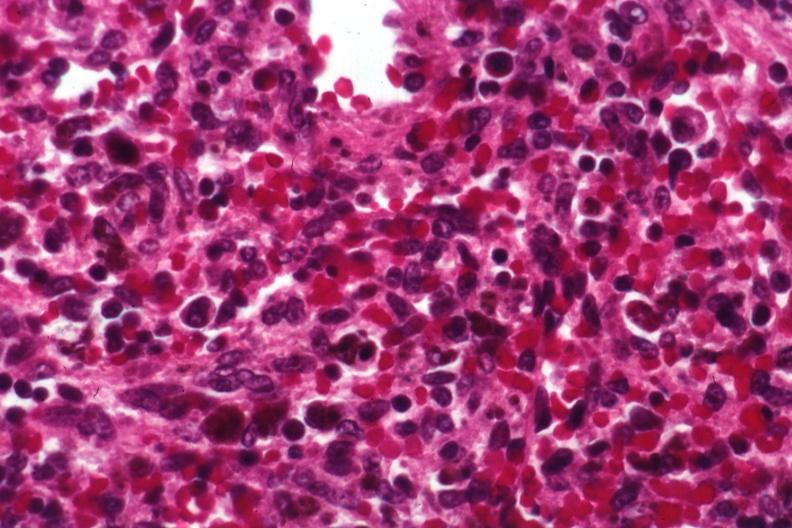what is present?
Answer the question using a single word or phrase. Erythrophagocytosis new born 